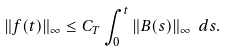Convert formula to latex. <formula><loc_0><loc_0><loc_500><loc_500>\| f ( t ) \| _ { \infty } \leq C _ { T } \int _ { 0 } ^ { t } \| B ( s ) \| _ { \infty } \ d s .</formula> 